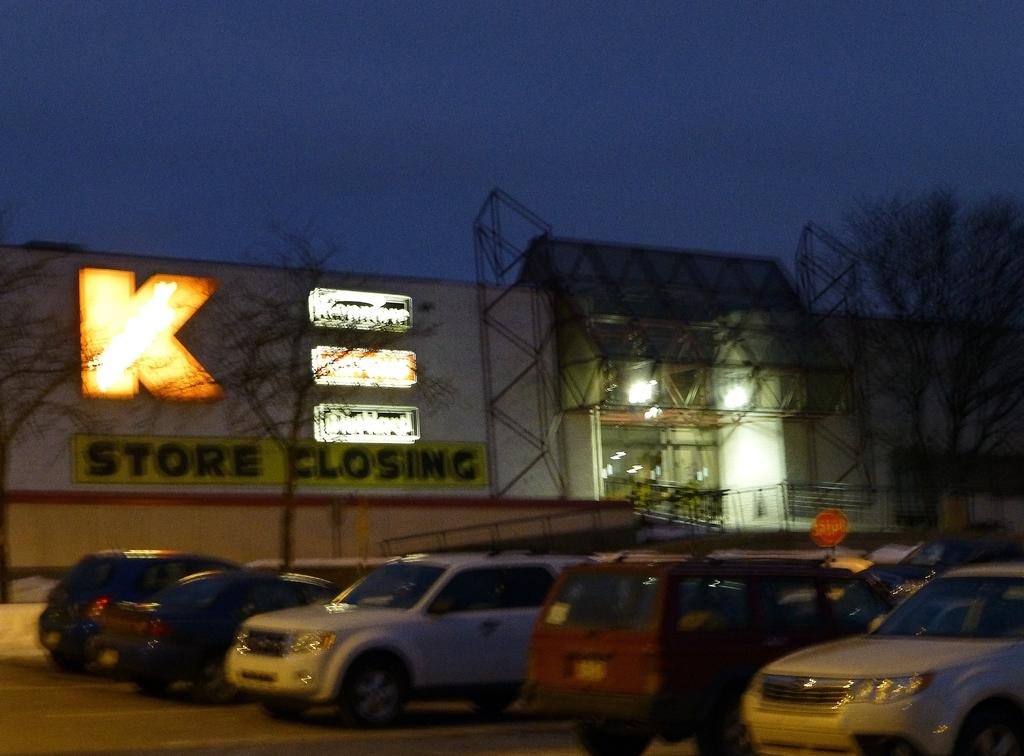Provide a one-sentence caption for the provided image. Cars are parked in an outdoor lot in front of a store that is going to be closing. 